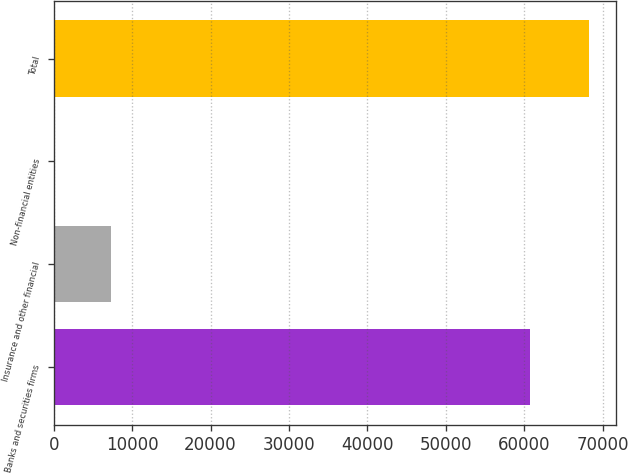Convert chart. <chart><loc_0><loc_0><loc_500><loc_500><bar_chart><fcel>Banks and securities firms<fcel>Insurance and other financial<fcel>Non-financial entities<fcel>Total<nl><fcel>60728<fcel>7313<fcel>226<fcel>68267<nl></chart> 